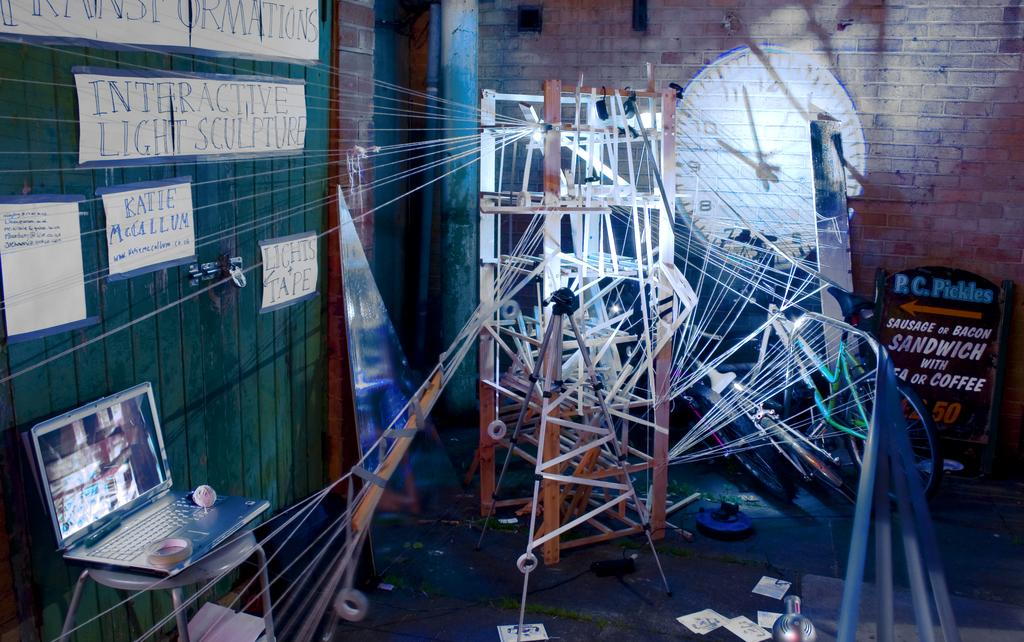<image>
Share a concise interpretation of the image provided. a laptop up against the wall with a sign that has R.C.Pickles pointing to the left 